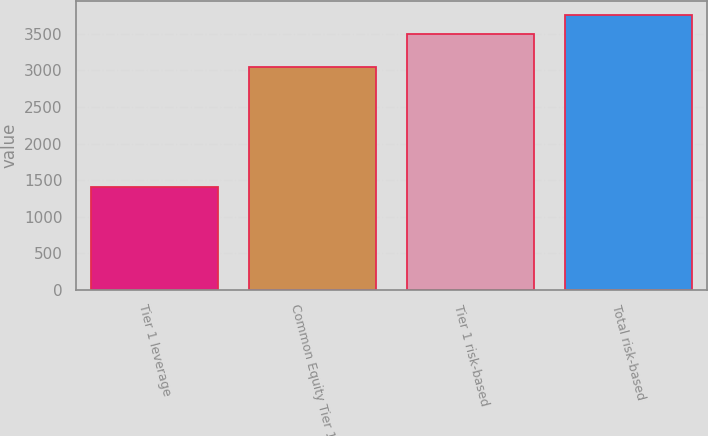Convert chart. <chart><loc_0><loc_0><loc_500><loc_500><bar_chart><fcel>Tier 1 leverage<fcel>Common Equity Tier 1<fcel>Tier 1 risk-based<fcel>Total risk-based<nl><fcel>1410<fcel>3051<fcel>3497<fcel>3763<nl></chart> 